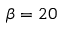<formula> <loc_0><loc_0><loc_500><loc_500>\beta = 2 0</formula> 